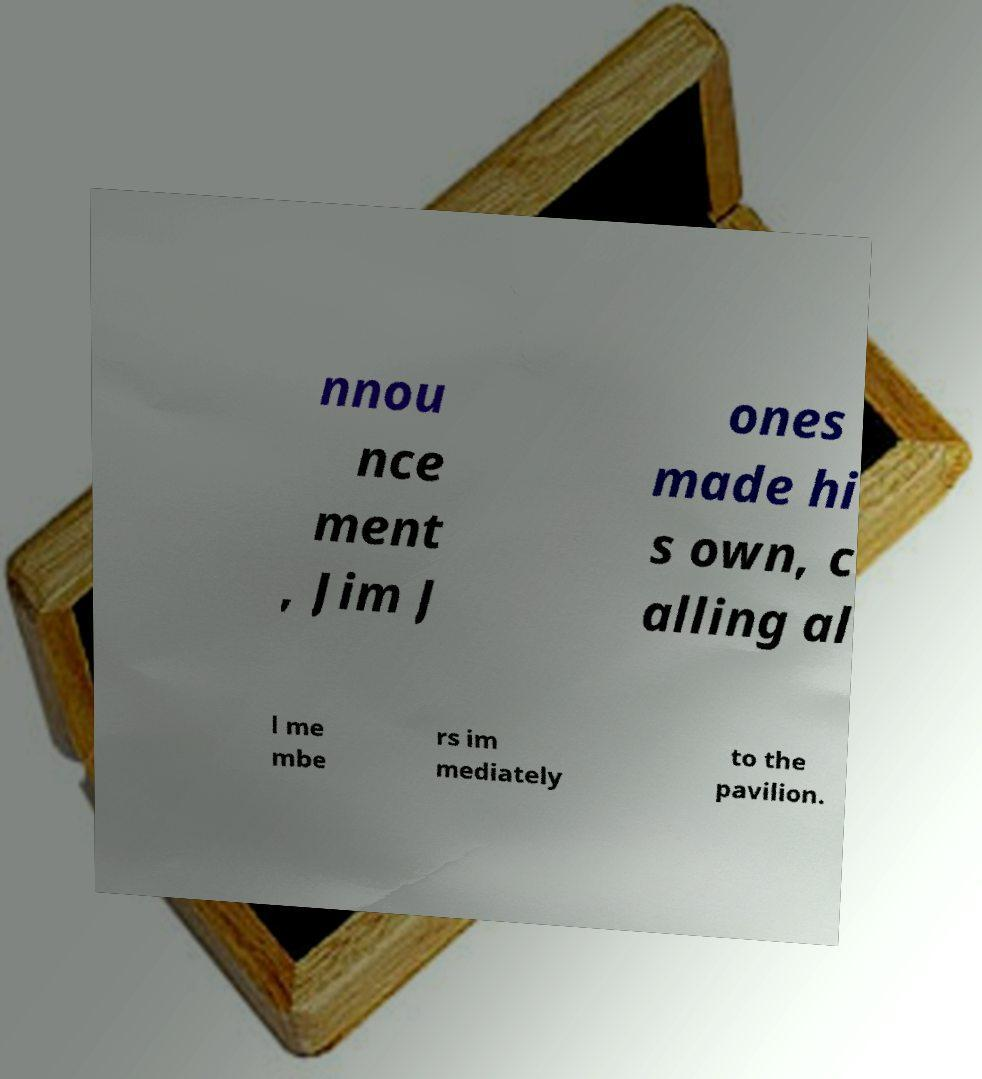There's text embedded in this image that I need extracted. Can you transcribe it verbatim? nnou nce ment , Jim J ones made hi s own, c alling al l me mbe rs im mediately to the pavilion. 